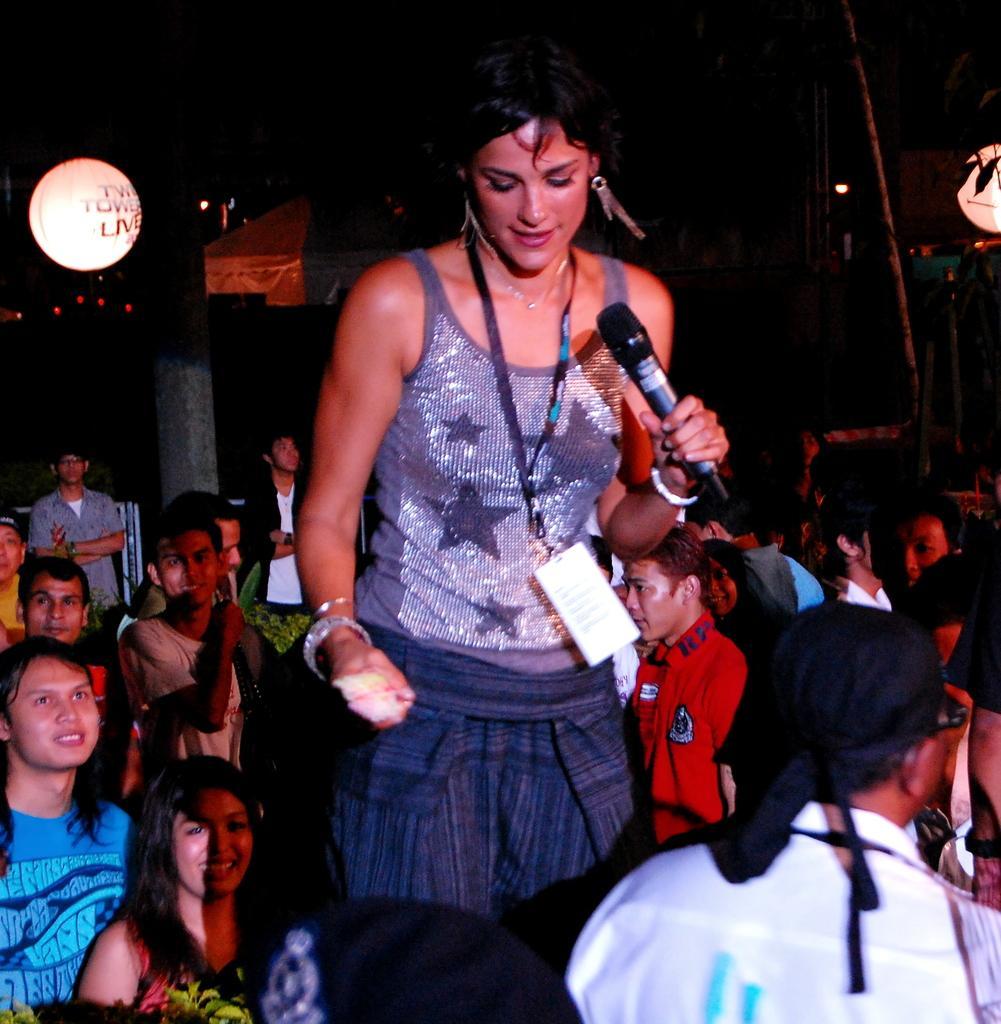Could you give a brief overview of what you see in this image? This picture is clicked outside the city. We can see women standing and holding microphone in her hands. She is wearing ID card and she is smiling. To the right bottom, we can see a man wearing black color cloth on his head and he is wearing white shirt. We see many people standing on the street and behind them, we see a pillar and behind the pillar, we see a house roof. 